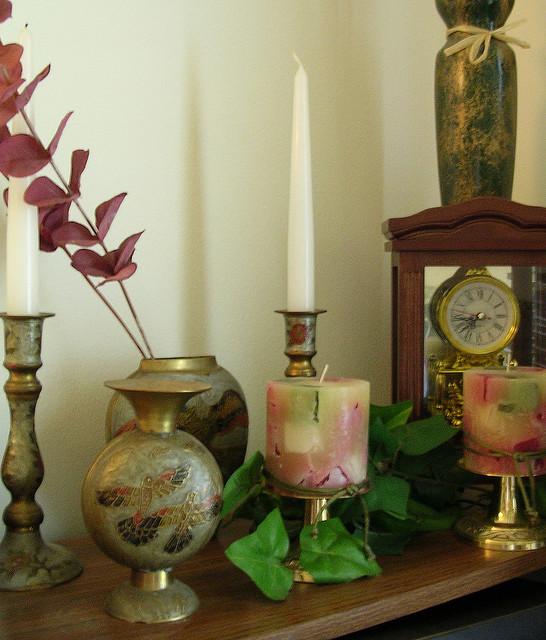Are there candles her?
Short answer required. Yes. Have the candles been used?
Short answer required. No. Are the plants fake?
Short answer required. Yes. Are the flowers artificial?
Give a very brief answer. Yes. How many vases are there?
Short answer required. 2. What figure is holding the clock?
Be succinct. Man. Are these on display?
Short answer required. Yes. What time does the clock say?
Keep it brief. 7:45. 